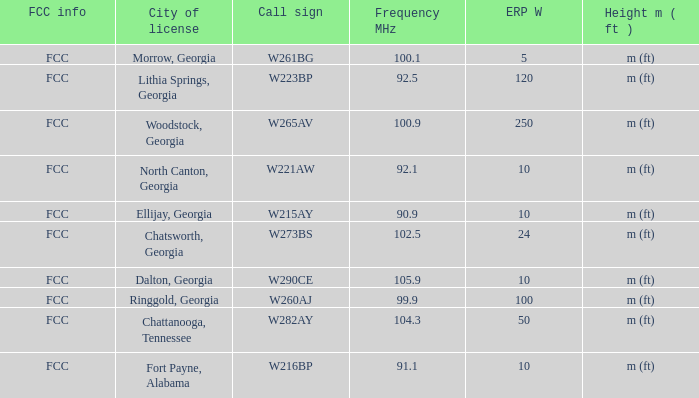How many ERP W is it that has a Call sign of w273bs? 24.0. 